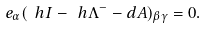Convert formula to latex. <formula><loc_0><loc_0><loc_500><loc_500>e _ { \alpha } ( \ h { I } - \ h { \Lambda } ^ { - } - d A ) _ { \beta \gamma } = 0 .</formula> 